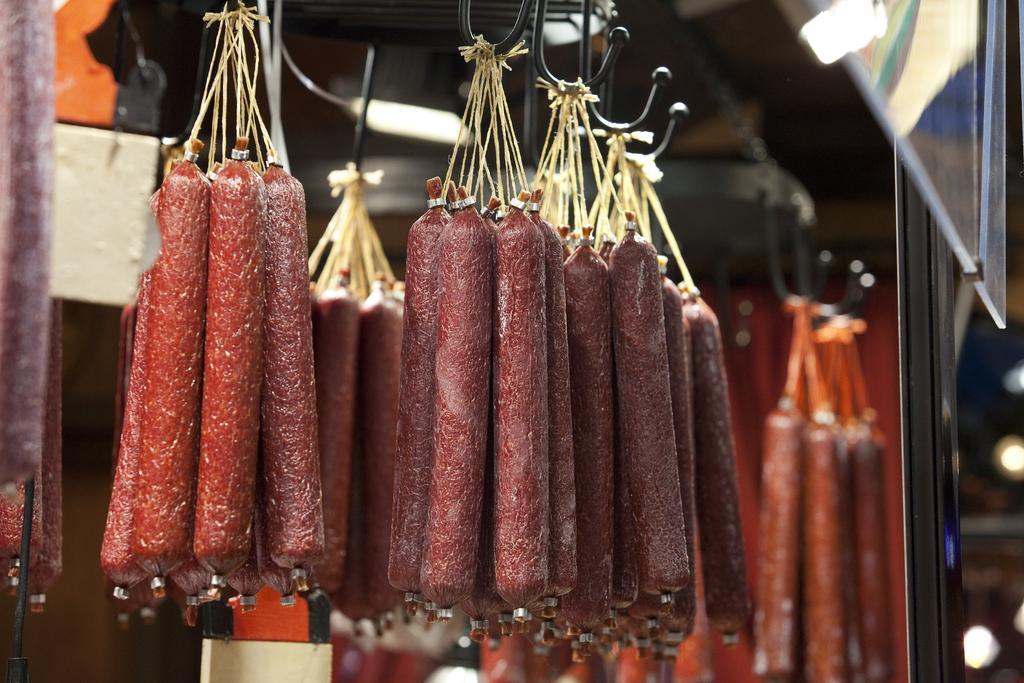Describe this image in one or two sentences. In this image I can see sausages are hanged on metal rods. In the background I can see a wall, lights and a door. This image is taken may be in a restaurant. 